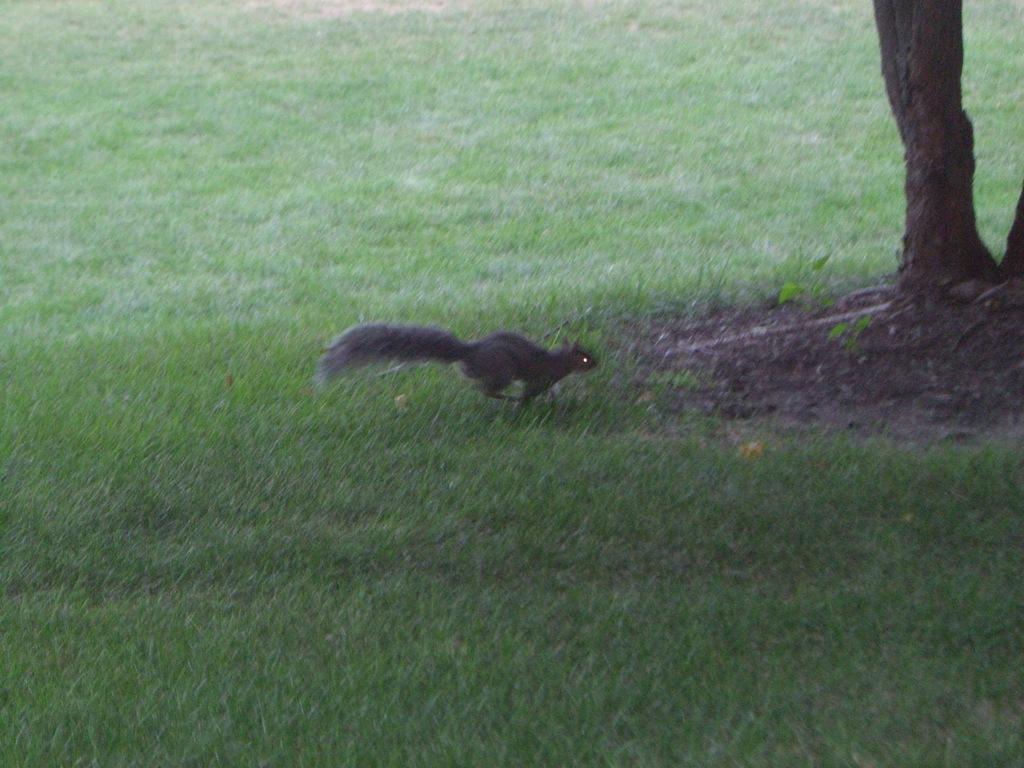Describe this image in one or two sentences. In the image there is a black squirrel running on the grass, in front of the squirrel there is a tree trunk. 